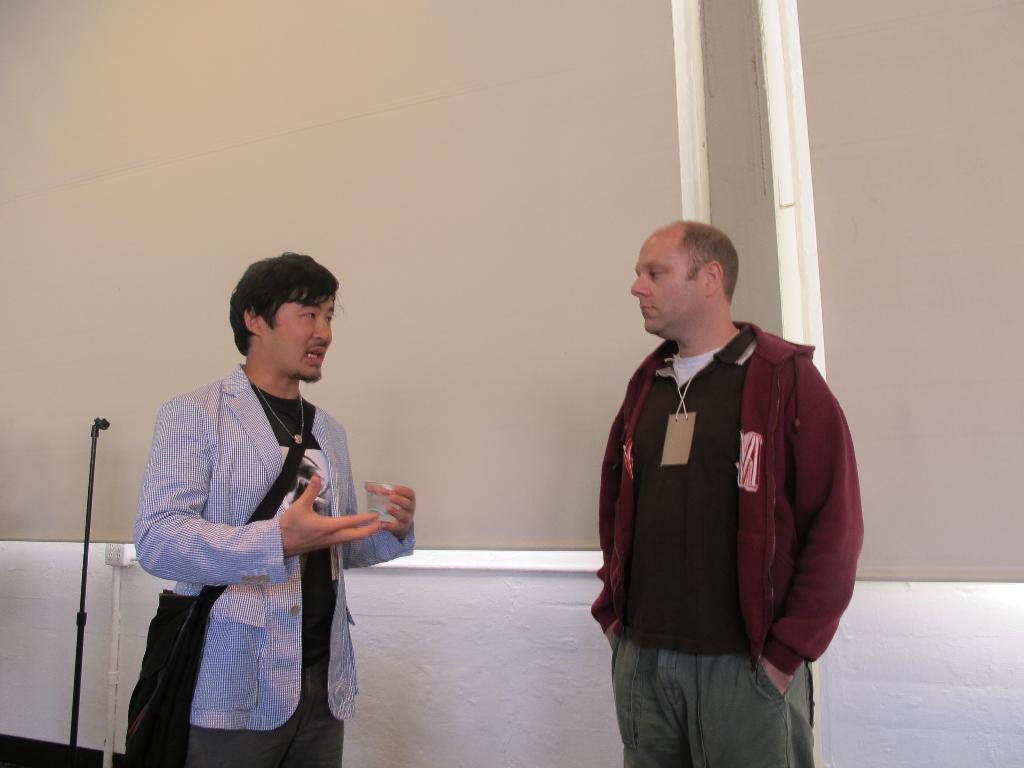In one or two sentences, can you explain what this image depicts? In this picture there are two men in the center of the image. 